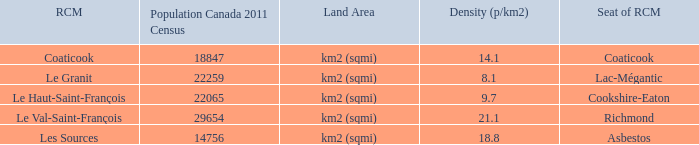What is the RCM that has a density of 9.7? Le Haut-Saint-François. 